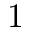<formula> <loc_0><loc_0><loc_500><loc_500>1</formula> 